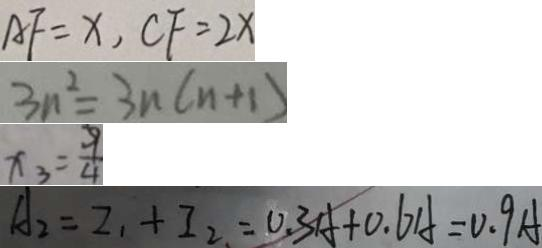Convert formula to latex. <formula><loc_0><loc_0><loc_500><loc_500>A F = x , C F = 2 x 
 3 n ^ { 2 } = 3 n ( n + 1 ) 
 x _ { 3 } = \frac { 9 } { 4 } 
 A _ { 2 } = I _ { 1 } + I _ { 2 } = 0 . 3 A + 0 . 6 A = 0 . 9 A</formula> 